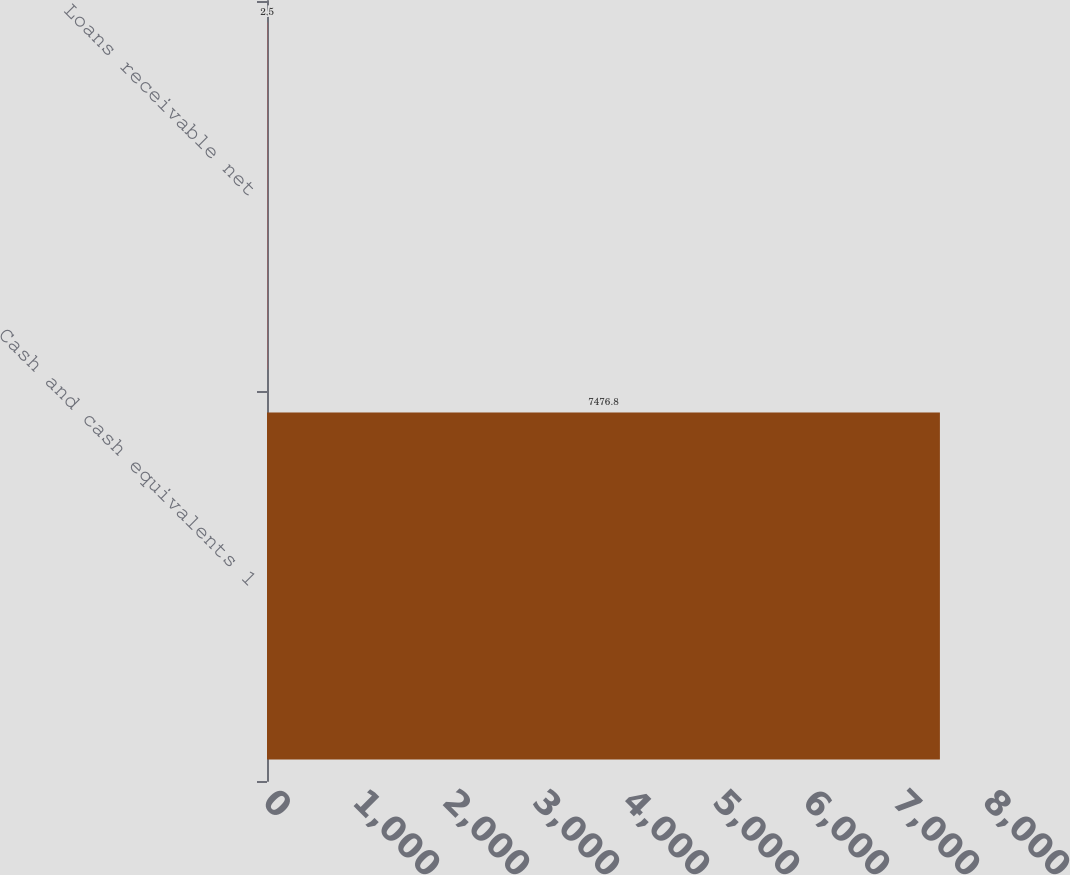<chart> <loc_0><loc_0><loc_500><loc_500><bar_chart><fcel>Cash and cash equivalents 1<fcel>Loans receivable net<nl><fcel>7476.8<fcel>2.5<nl></chart> 